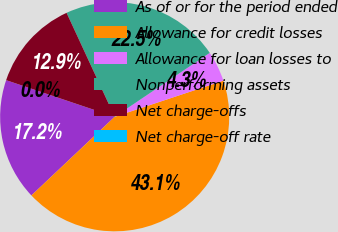Convert chart. <chart><loc_0><loc_0><loc_500><loc_500><pie_chart><fcel>As of or for the period ended<fcel>Allowance for credit losses<fcel>Allowance for loan losses to<fcel>Nonperforming assets<fcel>Net charge-offs<fcel>Net charge-off rate<nl><fcel>17.23%<fcel>43.06%<fcel>4.31%<fcel>22.48%<fcel>12.92%<fcel>0.0%<nl></chart> 